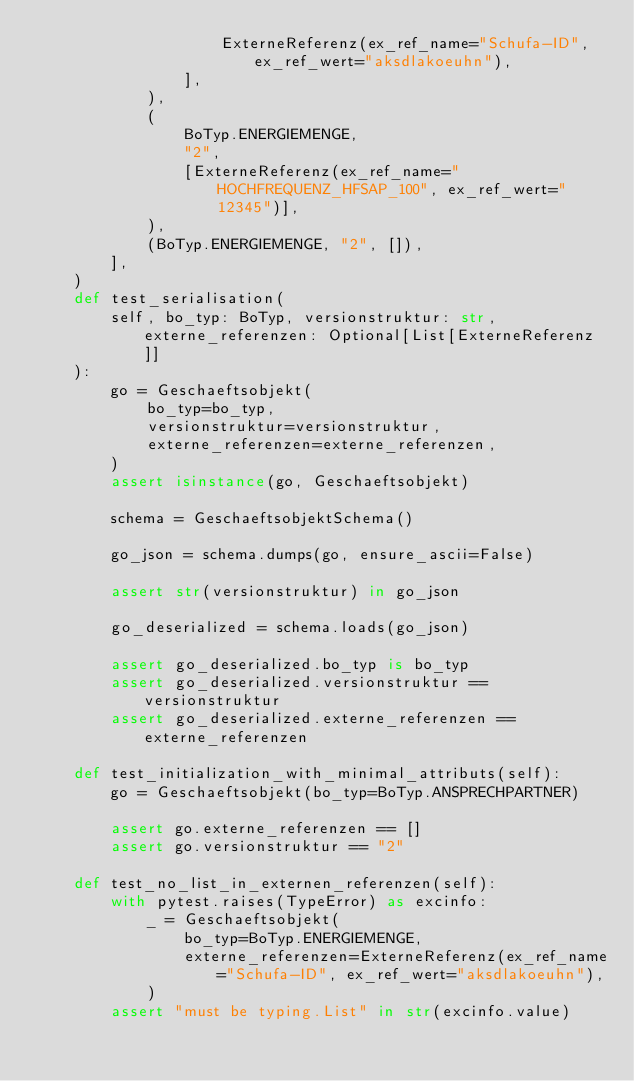<code> <loc_0><loc_0><loc_500><loc_500><_Python_>                    ExterneReferenz(ex_ref_name="Schufa-ID", ex_ref_wert="aksdlakoeuhn"),
                ],
            ),
            (
                BoTyp.ENERGIEMENGE,
                "2",
                [ExterneReferenz(ex_ref_name="HOCHFREQUENZ_HFSAP_100", ex_ref_wert="12345")],
            ),
            (BoTyp.ENERGIEMENGE, "2", []),
        ],
    )
    def test_serialisation(
        self, bo_typ: BoTyp, versionstruktur: str, externe_referenzen: Optional[List[ExterneReferenz]]
    ):
        go = Geschaeftsobjekt(
            bo_typ=bo_typ,
            versionstruktur=versionstruktur,
            externe_referenzen=externe_referenzen,
        )
        assert isinstance(go, Geschaeftsobjekt)

        schema = GeschaeftsobjektSchema()

        go_json = schema.dumps(go, ensure_ascii=False)

        assert str(versionstruktur) in go_json

        go_deserialized = schema.loads(go_json)

        assert go_deserialized.bo_typ is bo_typ
        assert go_deserialized.versionstruktur == versionstruktur
        assert go_deserialized.externe_referenzen == externe_referenzen

    def test_initialization_with_minimal_attributs(self):
        go = Geschaeftsobjekt(bo_typ=BoTyp.ANSPRECHPARTNER)

        assert go.externe_referenzen == []
        assert go.versionstruktur == "2"

    def test_no_list_in_externen_referenzen(self):
        with pytest.raises(TypeError) as excinfo:
            _ = Geschaeftsobjekt(
                bo_typ=BoTyp.ENERGIEMENGE,
                externe_referenzen=ExterneReferenz(ex_ref_name="Schufa-ID", ex_ref_wert="aksdlakoeuhn"),
            )
        assert "must be typing.List" in str(excinfo.value)
</code> 